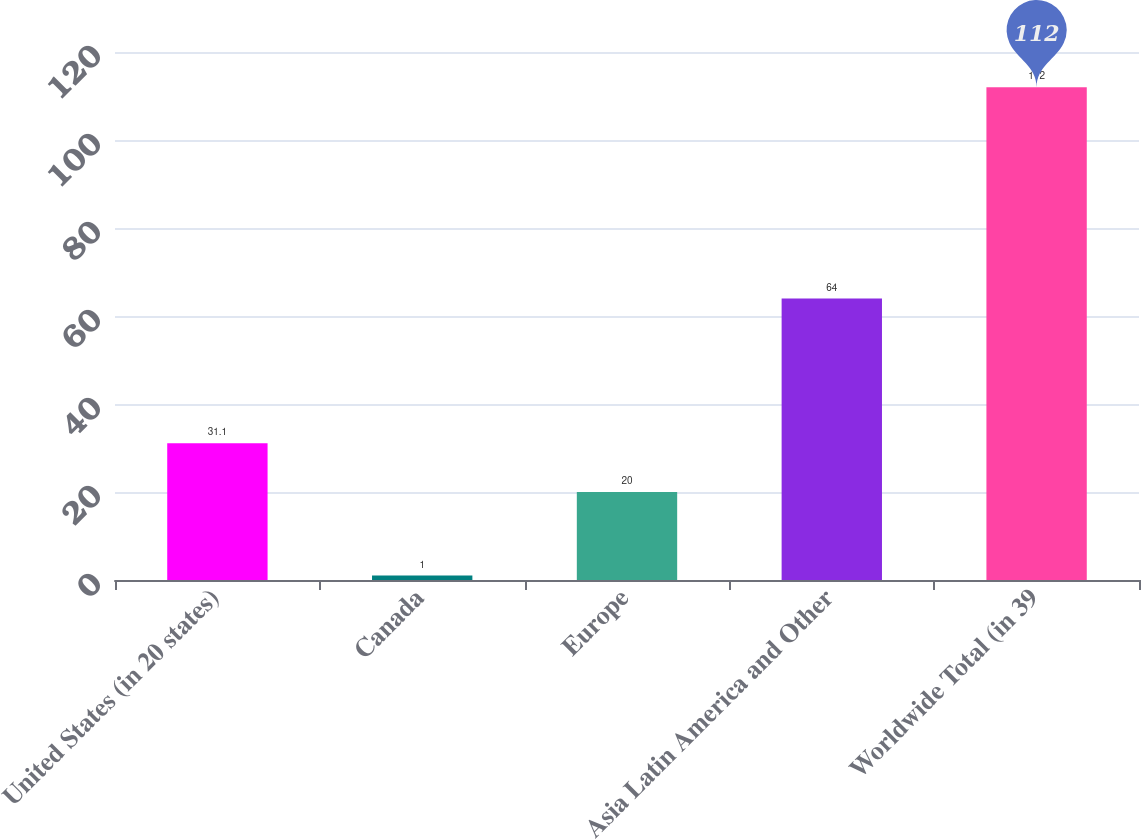Convert chart. <chart><loc_0><loc_0><loc_500><loc_500><bar_chart><fcel>United States (in 20 states)<fcel>Canada<fcel>Europe<fcel>Asia Latin America and Other<fcel>Worldwide Total (in 39<nl><fcel>31.1<fcel>1<fcel>20<fcel>64<fcel>112<nl></chart> 